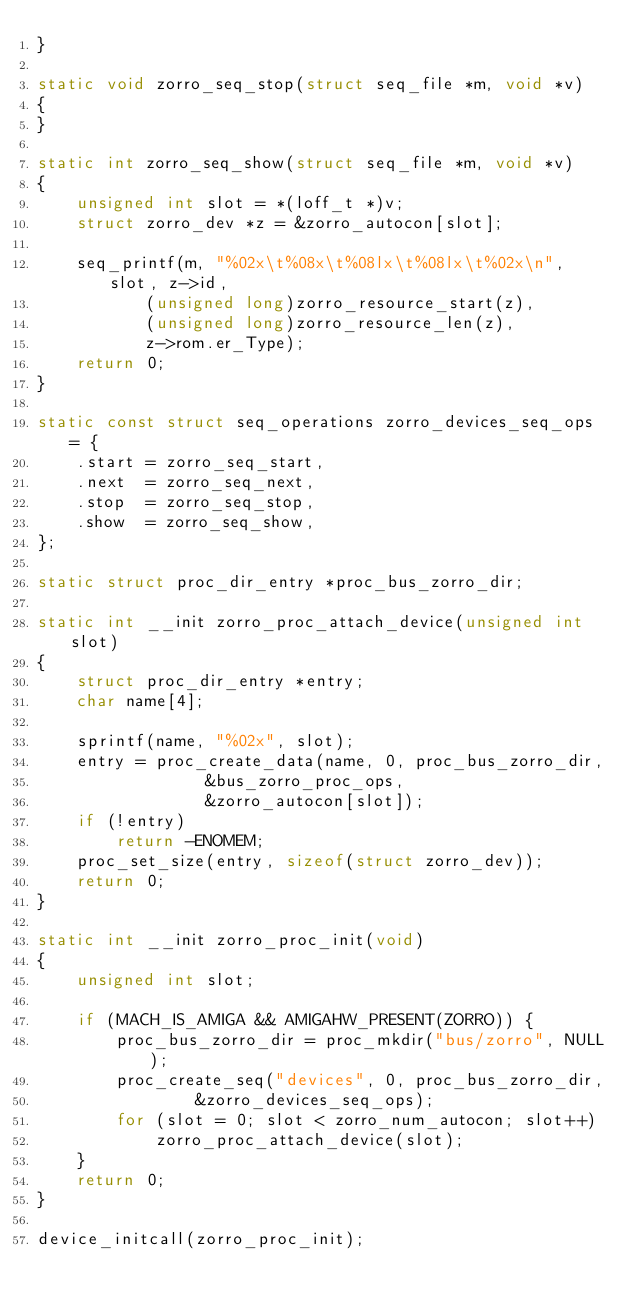<code> <loc_0><loc_0><loc_500><loc_500><_C_>}

static void zorro_seq_stop(struct seq_file *m, void *v)
{
}

static int zorro_seq_show(struct seq_file *m, void *v)
{
	unsigned int slot = *(loff_t *)v;
	struct zorro_dev *z = &zorro_autocon[slot];

	seq_printf(m, "%02x\t%08x\t%08lx\t%08lx\t%02x\n", slot, z->id,
		   (unsigned long)zorro_resource_start(z),
		   (unsigned long)zorro_resource_len(z),
		   z->rom.er_Type);
	return 0;
}

static const struct seq_operations zorro_devices_seq_ops = {
	.start = zorro_seq_start,
	.next  = zorro_seq_next,
	.stop  = zorro_seq_stop,
	.show  = zorro_seq_show,
};

static struct proc_dir_entry *proc_bus_zorro_dir;

static int __init zorro_proc_attach_device(unsigned int slot)
{
	struct proc_dir_entry *entry;
	char name[4];

	sprintf(name, "%02x", slot);
	entry = proc_create_data(name, 0, proc_bus_zorro_dir,
				 &bus_zorro_proc_ops,
				 &zorro_autocon[slot]);
	if (!entry)
		return -ENOMEM;
	proc_set_size(entry, sizeof(struct zorro_dev));
	return 0;
}

static int __init zorro_proc_init(void)
{
	unsigned int slot;

	if (MACH_IS_AMIGA && AMIGAHW_PRESENT(ZORRO)) {
		proc_bus_zorro_dir = proc_mkdir("bus/zorro", NULL);
		proc_create_seq("devices", 0, proc_bus_zorro_dir,
			    &zorro_devices_seq_ops);
		for (slot = 0; slot < zorro_num_autocon; slot++)
			zorro_proc_attach_device(slot);
	}
	return 0;
}

device_initcall(zorro_proc_init);
</code> 